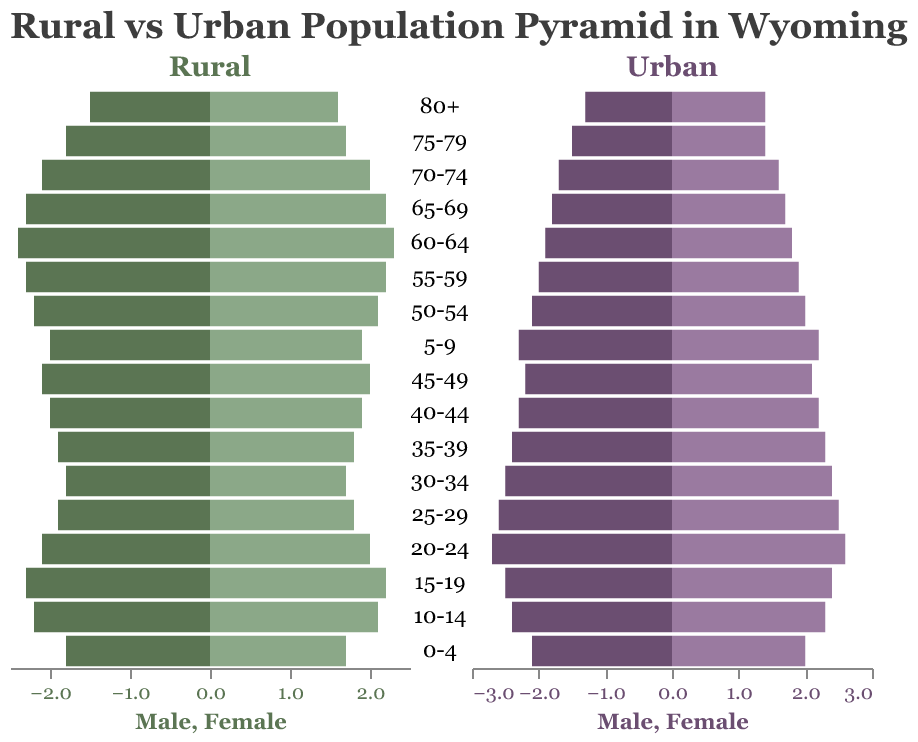What is the title of the figure? The title is displayed at the top of the figure in a larger font size to make it stand out. It indicates the main topic of the visualization.
Answer: Rural vs Urban Population Pyramid in Wyoming What age group has the highest percentage of males in rural areas? To find this, look at the bars representing rural males and see which is the longest. The percentages are listed along the x-axis.
Answer: 60-64 Which gender has a higher population percentage in urban areas for the age group 25-29? Compare the lengths of the bars for urban males and urban females in the 25-29 age group. The longer bar indicates a higher percentage.
Answer: Males What is the percentage difference between rural males and urban males in the 20-24 age group? Find the percentage values for rural and urban males in the 20-24 age group. Subtract the rural male value from the urban male value to get the difference.
Answer: 0.6 How does the percentage of rural females compare to urban females in the 70-74 age group? Compare the lengths of the bars representing rural females and urban females in the 70-74 age group.
Answer: Higher in rural areas Which age group has the smallest difference between male and female percentages in urban areas? Look at the urban sections and find the age group where the bars for males and females are closest in length. Calculate the differences for each group if necessary.
Answer: 80+ Are there more young children (0-4 years) or elderly (80+ years) in rural areas? Compare the bars representing the 0-4 years and 80+ years age groups for rural males and females.
Answer: Young children In which age group do urban females have a higher percentage than rural females? Compare the bars for urban and rural females in each age group. Identify the group(s) where the urban female bar is longer.
Answer: 20-24, 25-29, 30-34, 35-39, 40-44, 45-49, 50-54 What overall trend can you observe in the percentage of rural vs urban populations as age increases? Observe the general changes in bar lengths for rural and urban populations across different age groups.
Answer: Rural percentages generally increase with age, while urban percentages decrease Which age group shows a higher population percentage for urban males over rural males? Look through the age groups and identify where the urban male bar is longer than the rural male bar.
Answer: 20-24, 25-29, 30-34 